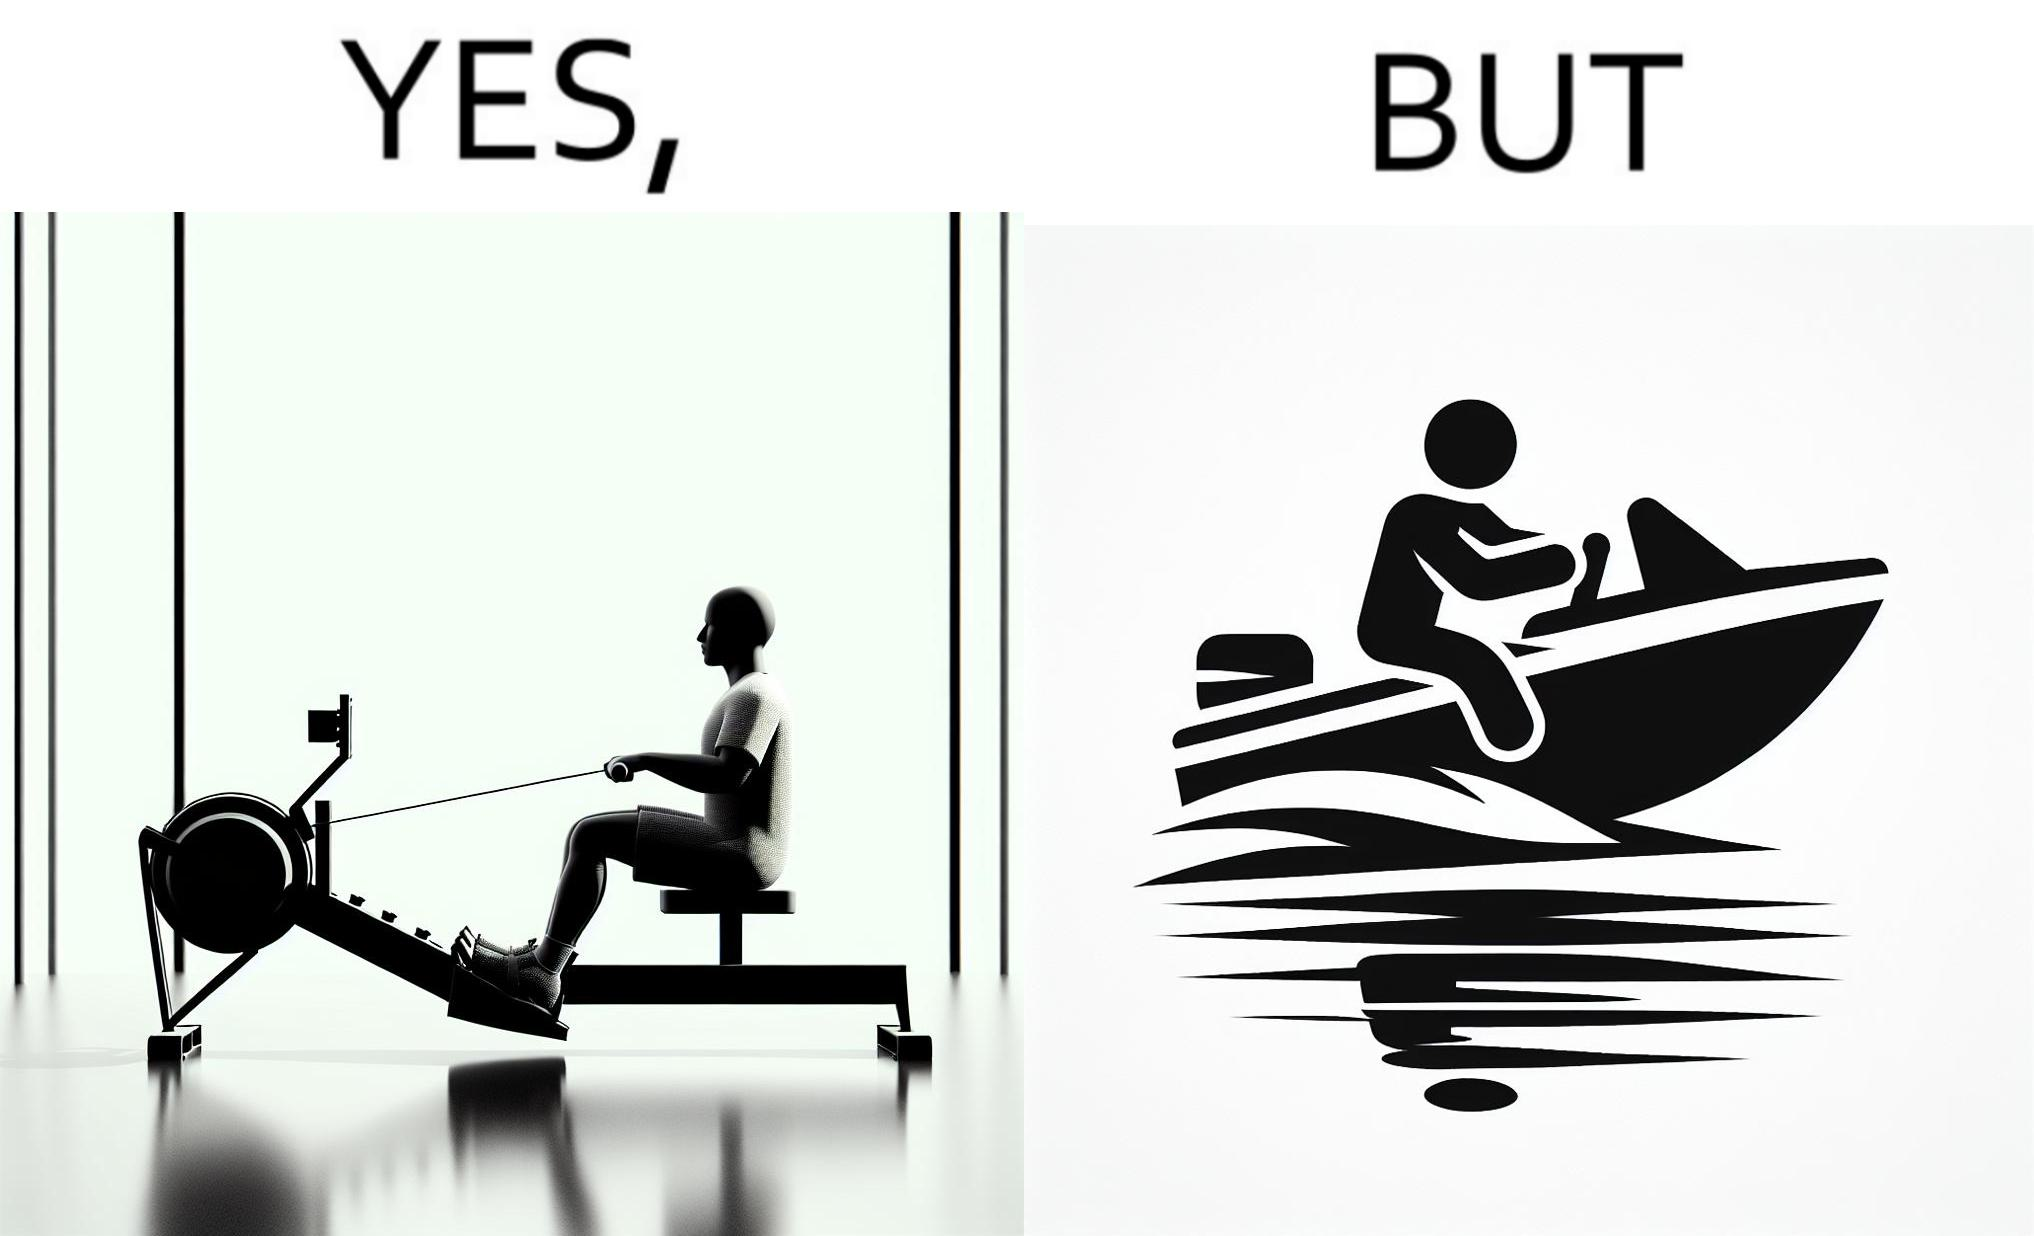Is there satirical content in this image? Yes, this image is satirical. 